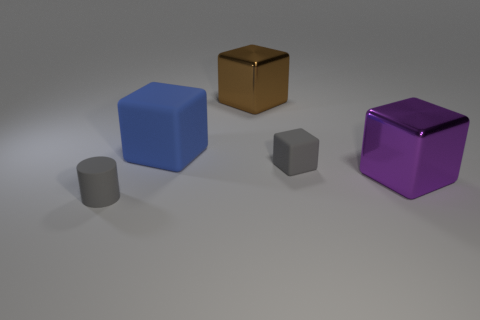Add 3 small gray things. How many objects exist? 8 Subtract all big matte blocks. How many blocks are left? 3 Subtract all brown blocks. How many blocks are left? 3 Subtract 2 blocks. How many blocks are left? 2 Subtract all blocks. How many objects are left? 1 Subtract 0 red cubes. How many objects are left? 5 Subtract all blue cylinders. Subtract all blue cubes. How many cylinders are left? 1 Subtract all green cylinders. How many blue cubes are left? 1 Subtract all tiny red shiny cylinders. Subtract all big blue matte things. How many objects are left? 4 Add 5 gray matte cubes. How many gray matte cubes are left? 6 